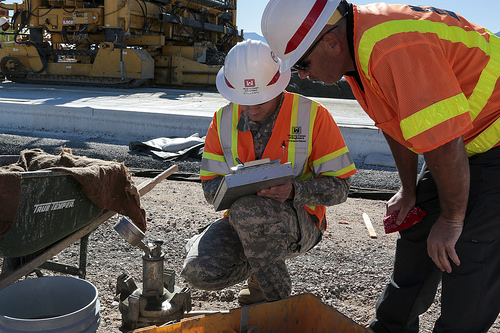<image>
Is there a worker to the left of the worker? Yes. From this viewpoint, the worker is positioned to the left side relative to the worker. 